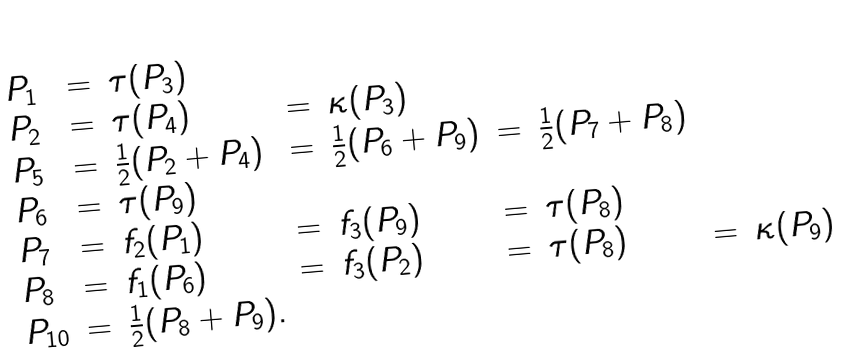Convert formula to latex. <formula><loc_0><loc_0><loc_500><loc_500>\begin{array} { l c l c l c l c l } P _ { 1 } & = & \tau ( P _ { 3 } ) \\ P _ { 2 } & = & \tau ( P _ { 4 } ) & = & \kappa ( P _ { 3 } ) \\ P _ { 5 } & = & \frac { 1 } { 2 } ( P _ { 2 } + P _ { 4 } ) & = & \frac { 1 } { 2 } ( P _ { 6 } + P _ { 9 } ) & = & \frac { 1 } { 2 } ( P _ { 7 } + P _ { 8 } ) \\ P _ { 6 } & = & \tau ( P _ { 9 } ) \\ P _ { 7 } & = & f _ { 2 } ( P _ { 1 } ) & = & f _ { 3 } ( P _ { 9 } ) & = & \tau ( P _ { 8 } ) \\ P _ { 8 } & = & f _ { 1 } ( P _ { 6 } ) & = & f _ { 3 } ( P _ { 2 } ) & = & \tau ( P _ { 8 } ) & = & \kappa ( P _ { 9 } ) \\ P _ { 1 0 } & = & \frac { 1 } { 2 } ( P _ { 8 } + P _ { 9 } ) . \end{array}</formula> 